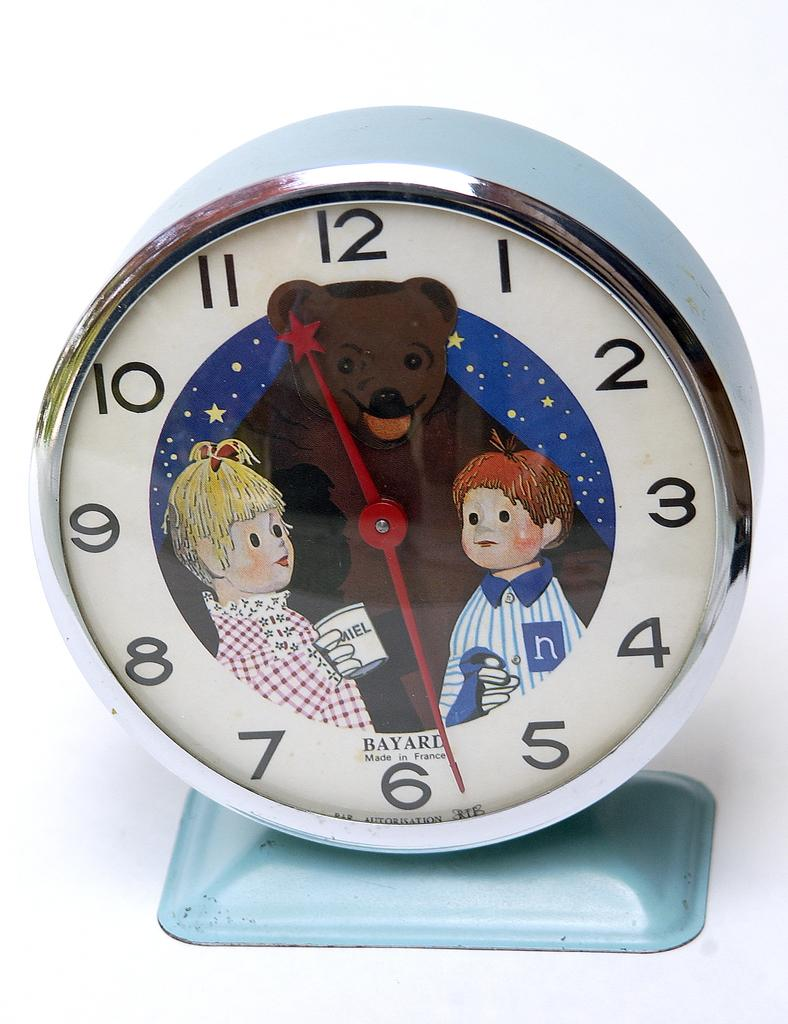<image>
Render a clear and concise summary of the photo. a clock that has 1 to 12 on it 